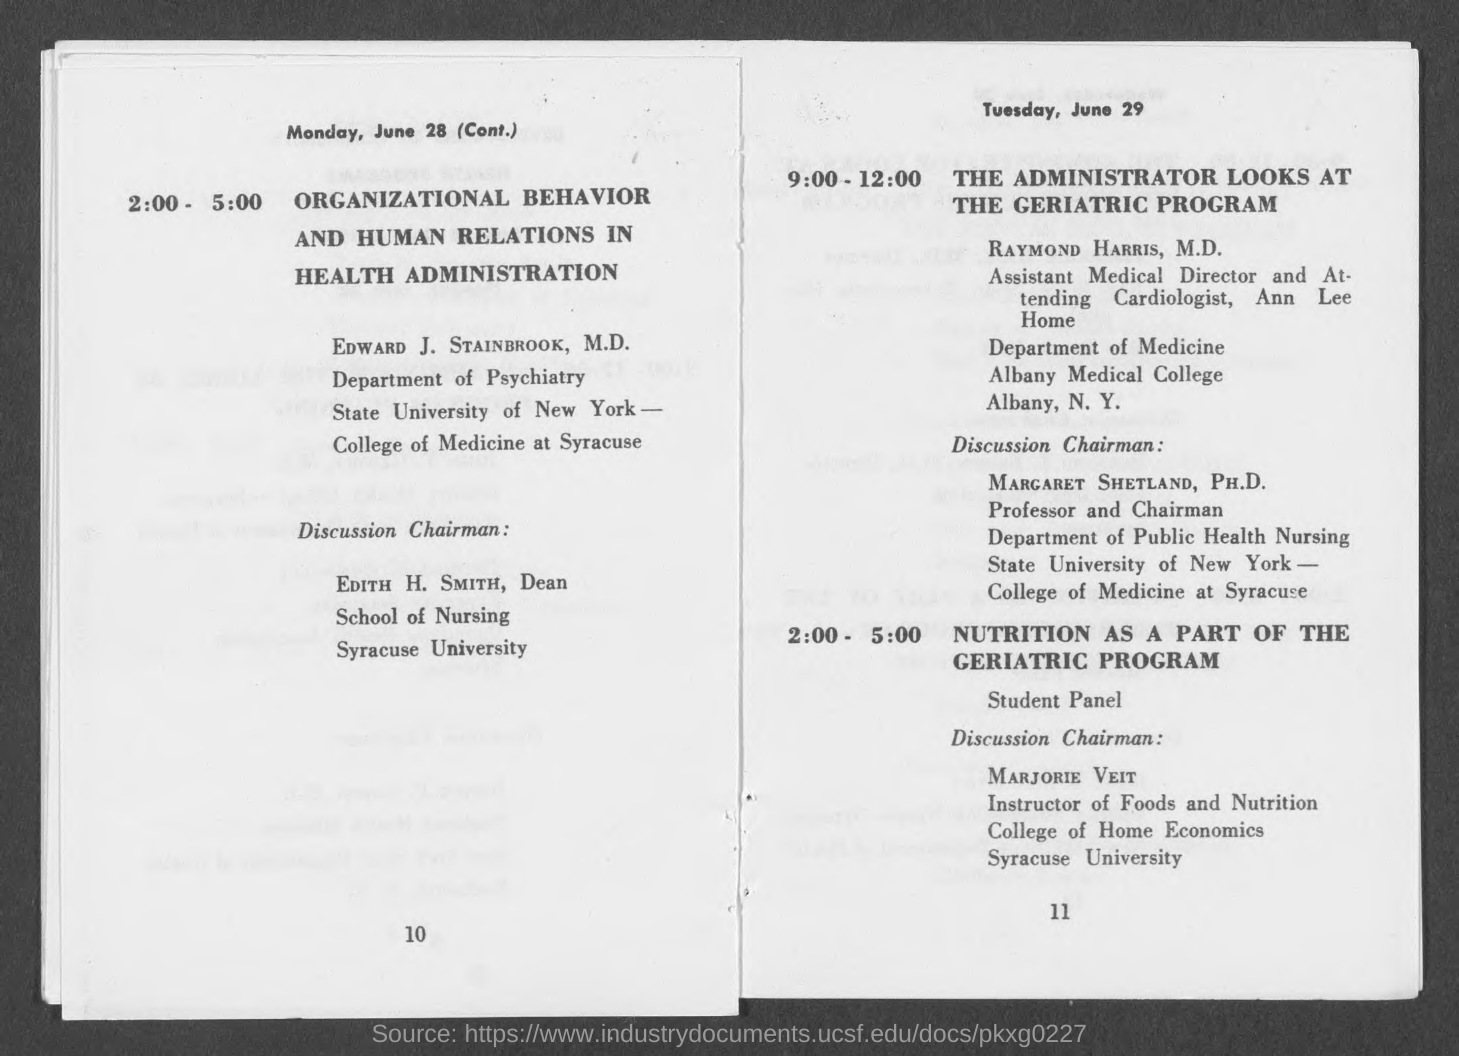What is the program from 2:00 - 5:00?
Provide a succinct answer. Organizational behavior and human relations in health administration. Who is the Discussion Chairman from 2:00 - 5:00 on June 28?
Your response must be concise. Edith H. Smith. Who is in charge of program from 9:00-12:00 on June 29?
Your answer should be very brief. Raymond Harris, M.D. Who is the Instructor of Foods and Nutrition?
Make the answer very short. Marjorie Veit. 